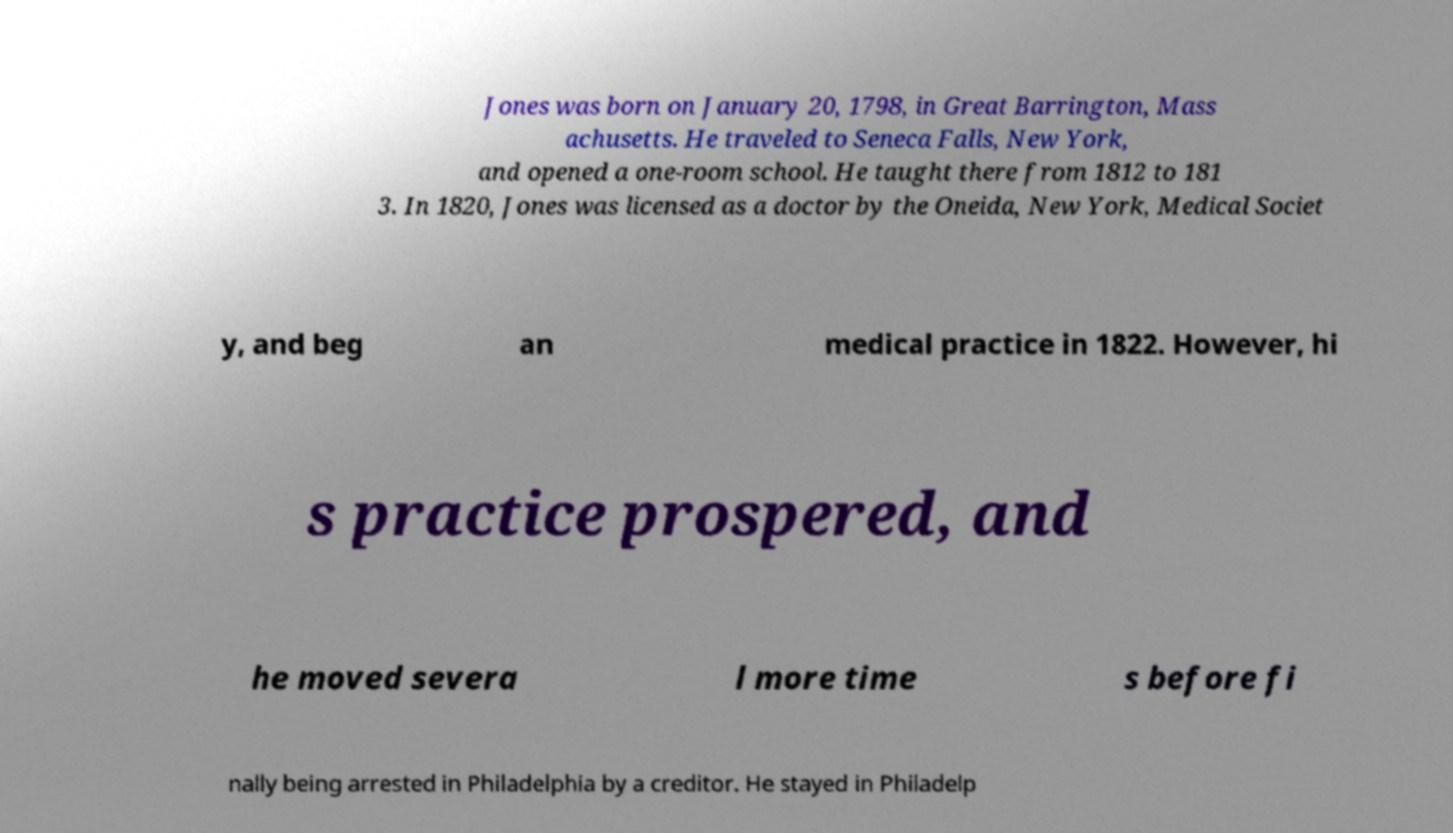For documentation purposes, I need the text within this image transcribed. Could you provide that? Jones was born on January 20, 1798, in Great Barrington, Mass achusetts. He traveled to Seneca Falls, New York, and opened a one-room school. He taught there from 1812 to 181 3. In 1820, Jones was licensed as a doctor by the Oneida, New York, Medical Societ y, and beg an medical practice in 1822. However, hi s practice prospered, and he moved severa l more time s before fi nally being arrested in Philadelphia by a creditor. He stayed in Philadelp 